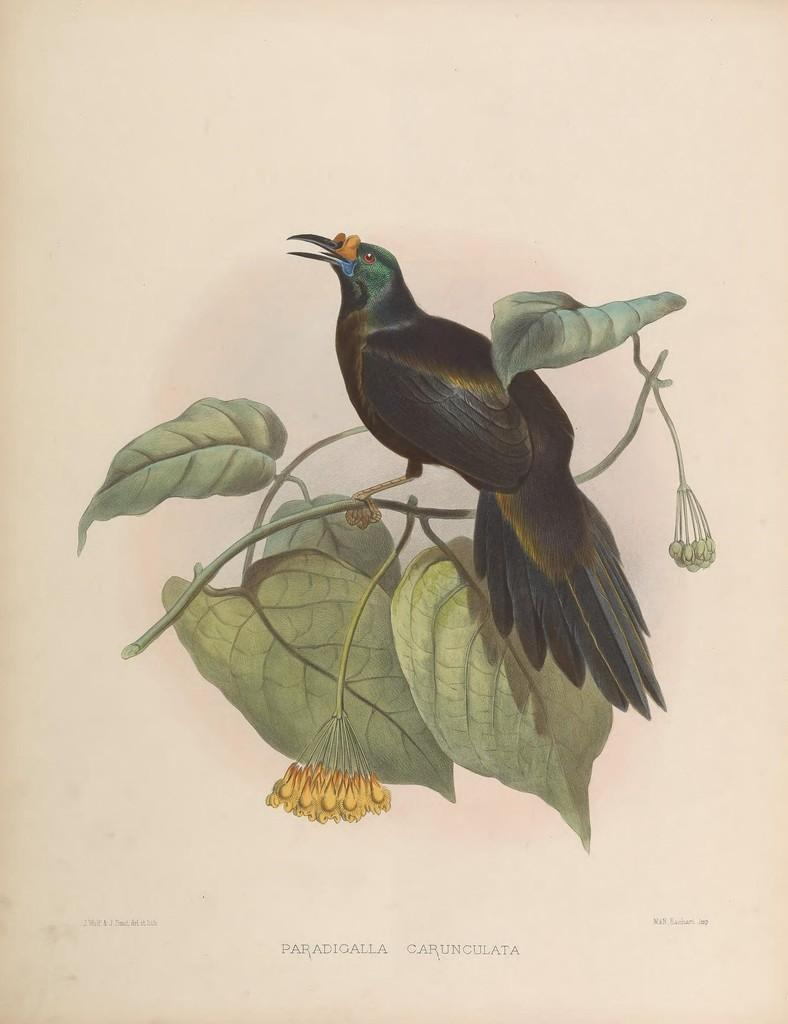What is depicted in the painting in the image? There is a painting of a bird in the image. What is the bird standing on in the painting? The bird is standing on a branch in the painting. What can be seen on the branch in the painting? The branch has leaves and flowers in the painting. What type of baseball equipment can be seen in the image? There is no baseball equipment present in the image; it features a painting of a bird on a branch with leaves and flowers. What industry is depicted in the image? The image does not depict any industry; it features a painting of a bird on a branch with leaves and flowers. 